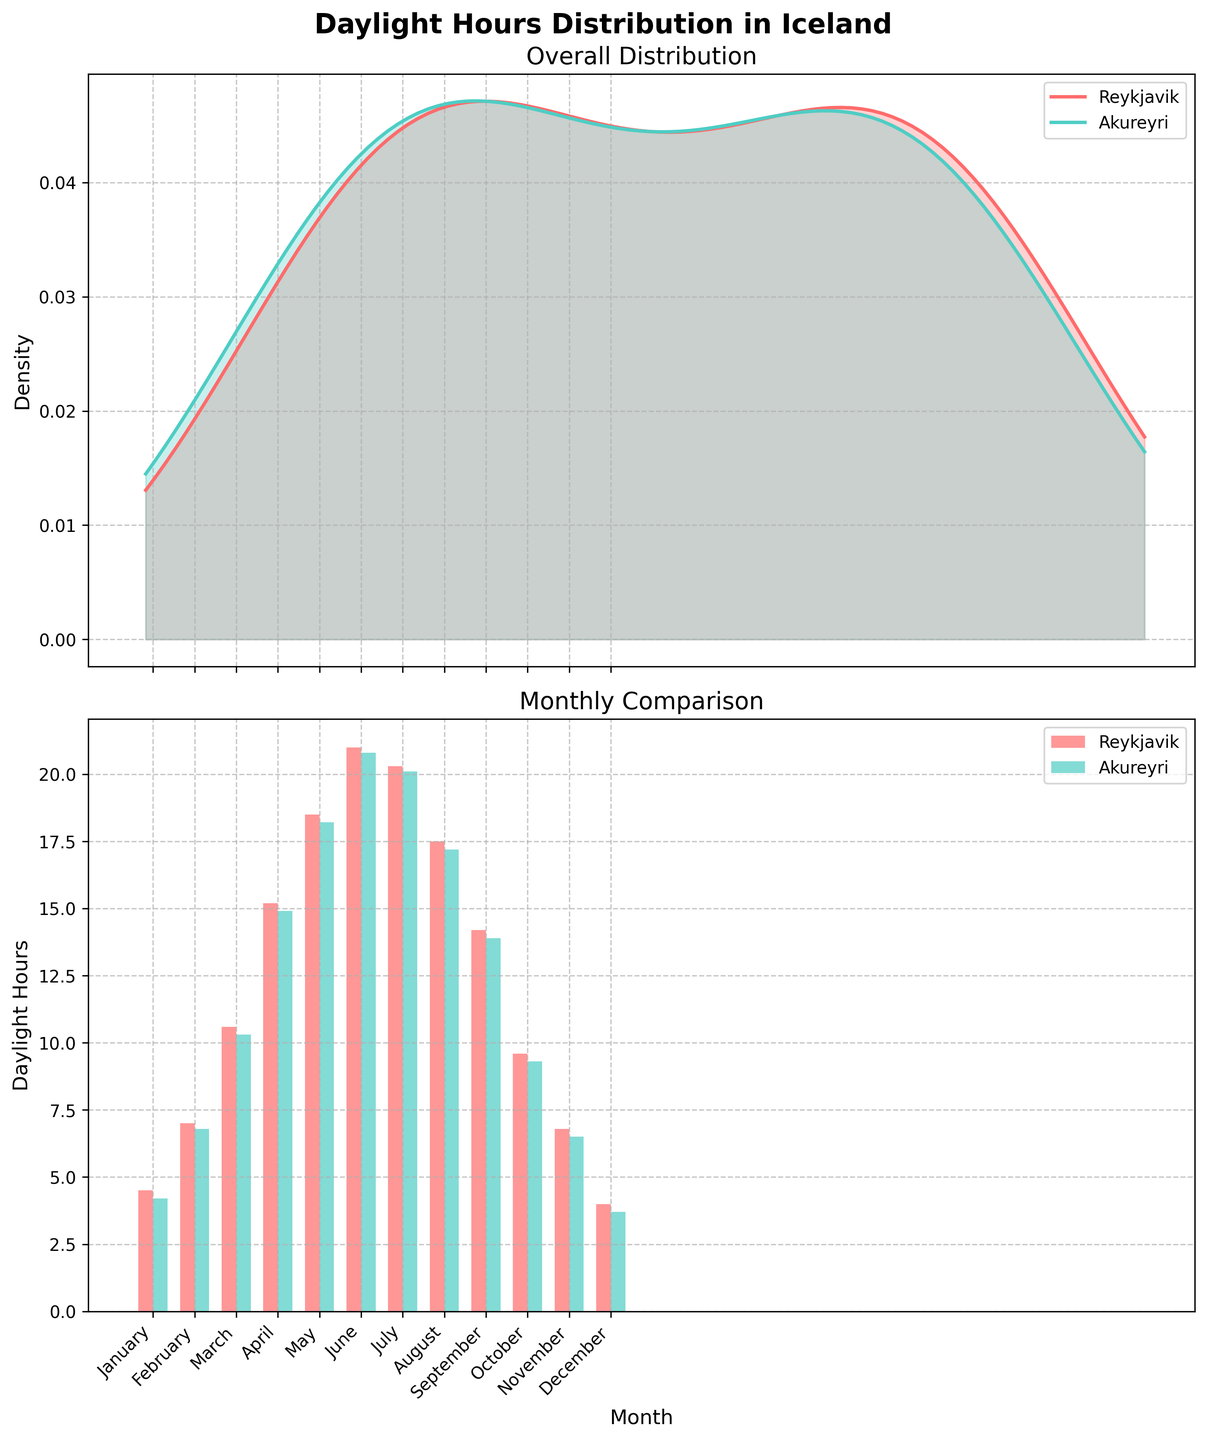How many locations are compared in the overall distribution plot? The overall distribution plot compares the density of daylight hours for two unique locations, as indicated by the legend.
Answer: 2 Which location has more daylight hours in January? By looking at the bar plot in the monthly comparison, Reykjavik has slightly more hours of daylight in January compared to Akureyri.
Answer: Reykjavik What is the peak density value for Reykjavik's daylight hours in the overall distribution plot? The peak density can be observed at the highest point of Reykjavik's curve in the overall distribution plot. Estimate this value by visually inspecting the graph.
Answer: Approximately 0.12 Which month shows the biggest difference in daylight hours between Reykjavik and Akureyri? To determine this, compare the daylight hours for each month in the bar plot to find the month with the largest disparity between the two locations. April stands out as having notable differences.
Answer: April How do daylight hours in July compare between Reykjavik and Akureyri? From the bar plot of the monthly comparison, the daylight hours in July for both locations are almost identical, with Reykjavik having a slight edge.
Answer: Reykjavik (20.3) is slightly higher than Akureyri (20.1) In which month do both locations experience the maximum daylight hours? By observing the bar plot in the monthly comparison, both locations experience their peak daylight hours around June.
Answer: June Is the overall density distribution symmetric for either location? Observe the shape of the density plots. If the curve looks evenly spread around the peak, it is symmetric. Here, neither Reykjavik's nor Akureyri's density distributions are perfectly symmetric.
Answer: No What can you infer about daylight hours in December for both locations? By looking at the bar plot for December, you can see that both Reykjavik and Akureyri experience the least amount of daylight hours, with Reykjavik having a bit more than Akureyri.
Answer: Both have the least daylight hours How do daylight hours trend throughout the year? By examining the bar plot, there is an observable trend where daylight hours increase from January, peak in the summer months (June/July), and then decrease towards December.
Answer: Increase in early year, peak in summer, decrease towards end What is the range of daylight hours for Akureyri in the overall distribution plot? This can be inferred from the x-axis range where Akureyri's density plot has non-zero values, which spans from approximately 3.7 to 20.8 hours.
Answer: Approximately 3.7 to 20.8 hours 